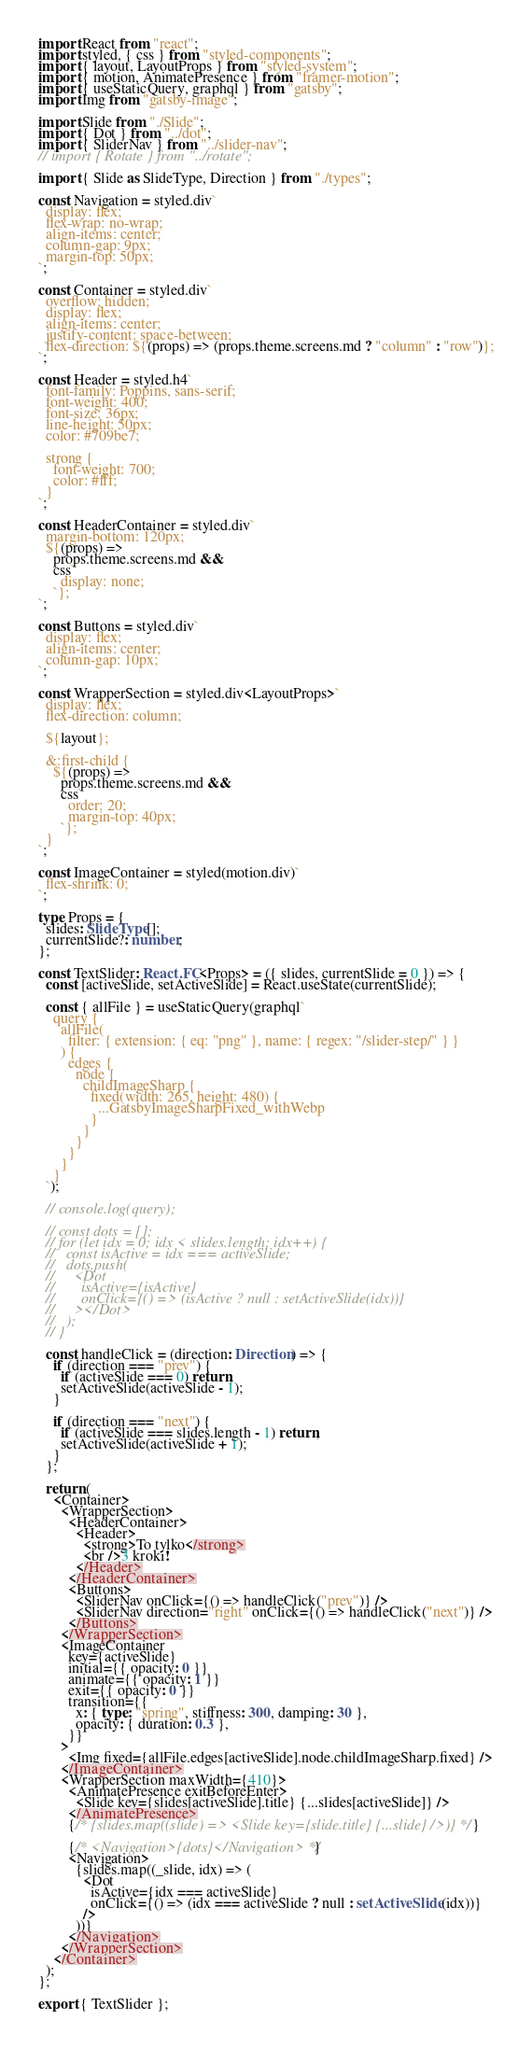Convert code to text. <code><loc_0><loc_0><loc_500><loc_500><_TypeScript_>import React from "react";
import styled, { css } from "styled-components";
import { layout, LayoutProps } from "styled-system";
import { motion, AnimatePresence } from "framer-motion";
import { useStaticQuery, graphql } from "gatsby";
import Img from "gatsby-image";

import Slide from "./Slide";
import { Dot } from "../dot";
import { SliderNav } from "../slider-nav";
// import { Rotate } from "../rotate";

import { Slide as SlideType, Direction } from "./types";

const Navigation = styled.div`
  display: flex;
  flex-wrap: no-wrap;
  align-items: center;
  column-gap: 9px;
  margin-top: 50px;
`;

const Container = styled.div`
  overflow: hidden;
  display: flex;
  align-items: center;
  justify-content: space-between;
  flex-direction: ${(props) => (props.theme.screens.md ? "column" : "row")};
`;

const Header = styled.h4`
  font-family: Poppins, sans-serif;
  font-weight: 400;
  font-size: 36px;
  line-height: 50px;
  color: #709be7;

  strong {
    font-weight: 700;
    color: #fff;
  }
`;

const HeaderContainer = styled.div`
  margin-bottom: 120px;
  ${(props) =>
    props.theme.screens.md &&
    css`
      display: none;
    `};
`;

const Buttons = styled.div`
  display: flex;
  align-items: center;
  column-gap: 10px;
`;

const WrapperSection = styled.div<LayoutProps>`
  display: flex;
  flex-direction: column;

  ${layout};

  &:first-child {
    ${(props) =>
      props.theme.screens.md &&
      css`
        order: 20;
        margin-top: 40px;
      `};
  }
`;

const ImageContainer = styled(motion.div)`
  flex-shrink: 0;
`;

type Props = {
  slides: SlideType[];
  currentSlide?: number;
};

const TextSlider: React.FC<Props> = ({ slides, currentSlide = 0 }) => {
  const [activeSlide, setActiveSlide] = React.useState(currentSlide);

  const { allFile } = useStaticQuery(graphql`
    query {
      allFile(
        filter: { extension: { eq: "png" }, name: { regex: "/slider-step/" } }
      ) {
        edges {
          node {
            childImageSharp {
              fixed(width: 265, height: 480) {
                ...GatsbyImageSharpFixed_withWebp
              }
            }
          }
        }
      }
    }
  `);

  // console.log(query);

  // const dots = [];
  // for (let idx = 0; idx < slides.length; idx++) {
  //   const isActive = idx === activeSlide;
  //   dots.push(
  //     <Dot
  //       isActive={isActive}
  //       onClick={() => (isActive ? null : setActiveSlide(idx))}
  //     ></Dot>
  //   );
  // }

  const handleClick = (direction: Direction) => {
    if (direction === "prev") {
      if (activeSlide === 0) return;
      setActiveSlide(activeSlide - 1);
    }

    if (direction === "next") {
      if (activeSlide === slides.length - 1) return;
      setActiveSlide(activeSlide + 1);
    }
  };

  return (
    <Container>
      <WrapperSection>
        <HeaderContainer>
          <Header>
            <strong>To tylko</strong>
            <br />3 kroki!
          </Header>
        </HeaderContainer>
        <Buttons>
          <SliderNav onClick={() => handleClick("prev")} />
          <SliderNav direction="right" onClick={() => handleClick("next")} />
        </Buttons>
      </WrapperSection>
      <ImageContainer
        key={activeSlide}
        initial={{ opacity: 0 }}
        animate={{ opacity: 1 }}
        exit={{ opacity: 0 }}
        transition={{
          x: { type: "spring", stiffness: 300, damping: 30 },
          opacity: { duration: 0.3 },
        }}
      >
        <Img fixed={allFile.edges[activeSlide].node.childImageSharp.fixed} />
      </ImageContainer>
      <WrapperSection maxWidth={410}>
        <AnimatePresence exitBeforeEnter>
          <Slide key={slides[activeSlide].title} {...slides[activeSlide]} />
        </AnimatePresence>
        {/* {slides.map((slide) => <Slide key={slide.title} {...slide} />)} */}

        {/* <Navigation>{dots}</Navigation> */}
        <Navigation>
          {slides.map((_slide, idx) => (
            <Dot
              isActive={idx === activeSlide}
              onClick={() => (idx === activeSlide ? null : setActiveSlide(idx))}
            />
          ))}
        </Navigation>
      </WrapperSection>
    </Container>
  );
};

export { TextSlider };
</code> 